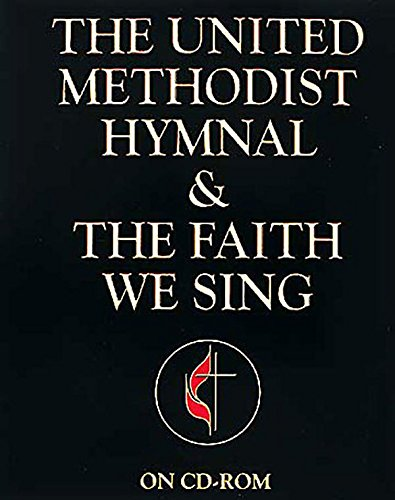What might be the typical contents of a hymnal like this one? A hymnal such as 'The United Methodist Hymnal & The Faith We Sing' typically contains a variety of church hymns, spiritual songs, and possibly liturgical texts used in worship. It serves as a vital tool during church services, enabling congregational singing and participation. Are there any special features in this edition of the hymnal? This edition of the hymnal is mentioned to be 'On CD-ROM,' which suggests it includes digital formats of the hymns. This feature allows for more accessible and versatile use in church services, including projecting lyrics for congregations or easily accessible accompaniment tracks. 